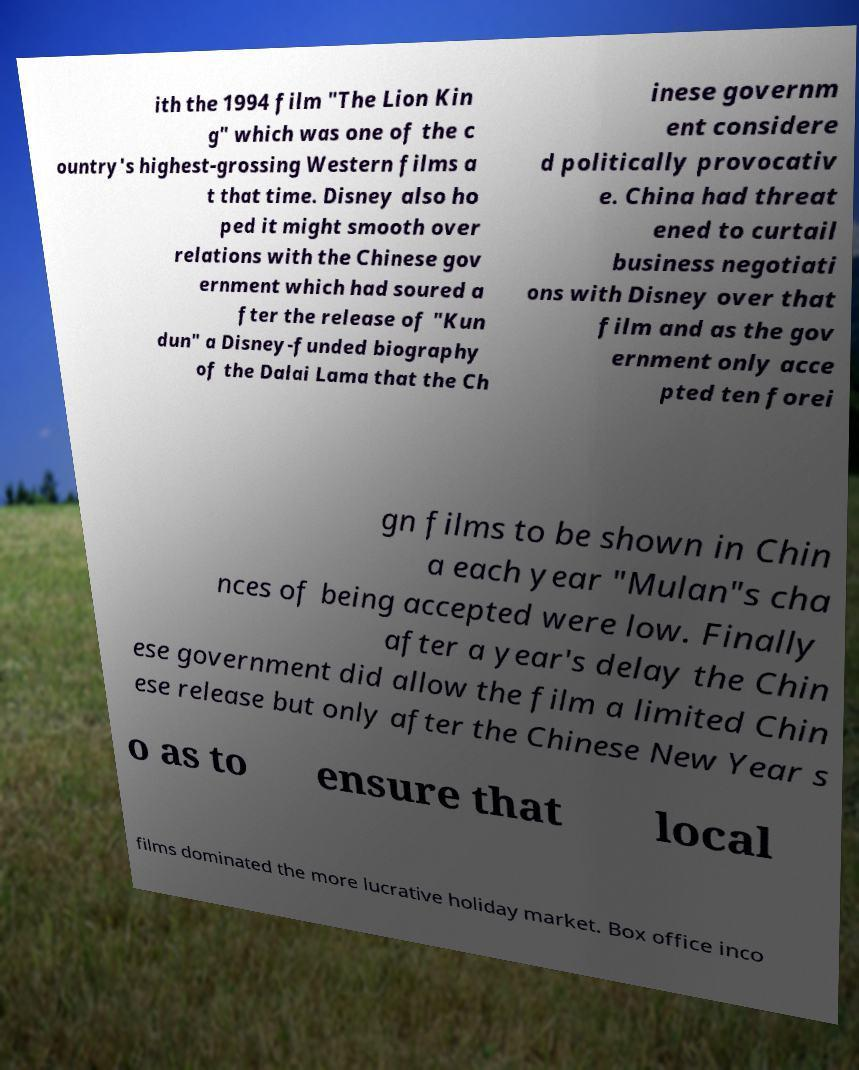What messages or text are displayed in this image? I need them in a readable, typed format. ith the 1994 film "The Lion Kin g" which was one of the c ountry's highest-grossing Western films a t that time. Disney also ho ped it might smooth over relations with the Chinese gov ernment which had soured a fter the release of "Kun dun" a Disney-funded biography of the Dalai Lama that the Ch inese governm ent considere d politically provocativ e. China had threat ened to curtail business negotiati ons with Disney over that film and as the gov ernment only acce pted ten forei gn films to be shown in Chin a each year "Mulan"s cha nces of being accepted were low. Finally after a year's delay the Chin ese government did allow the film a limited Chin ese release but only after the Chinese New Year s o as to ensure that local films dominated the more lucrative holiday market. Box office inco 